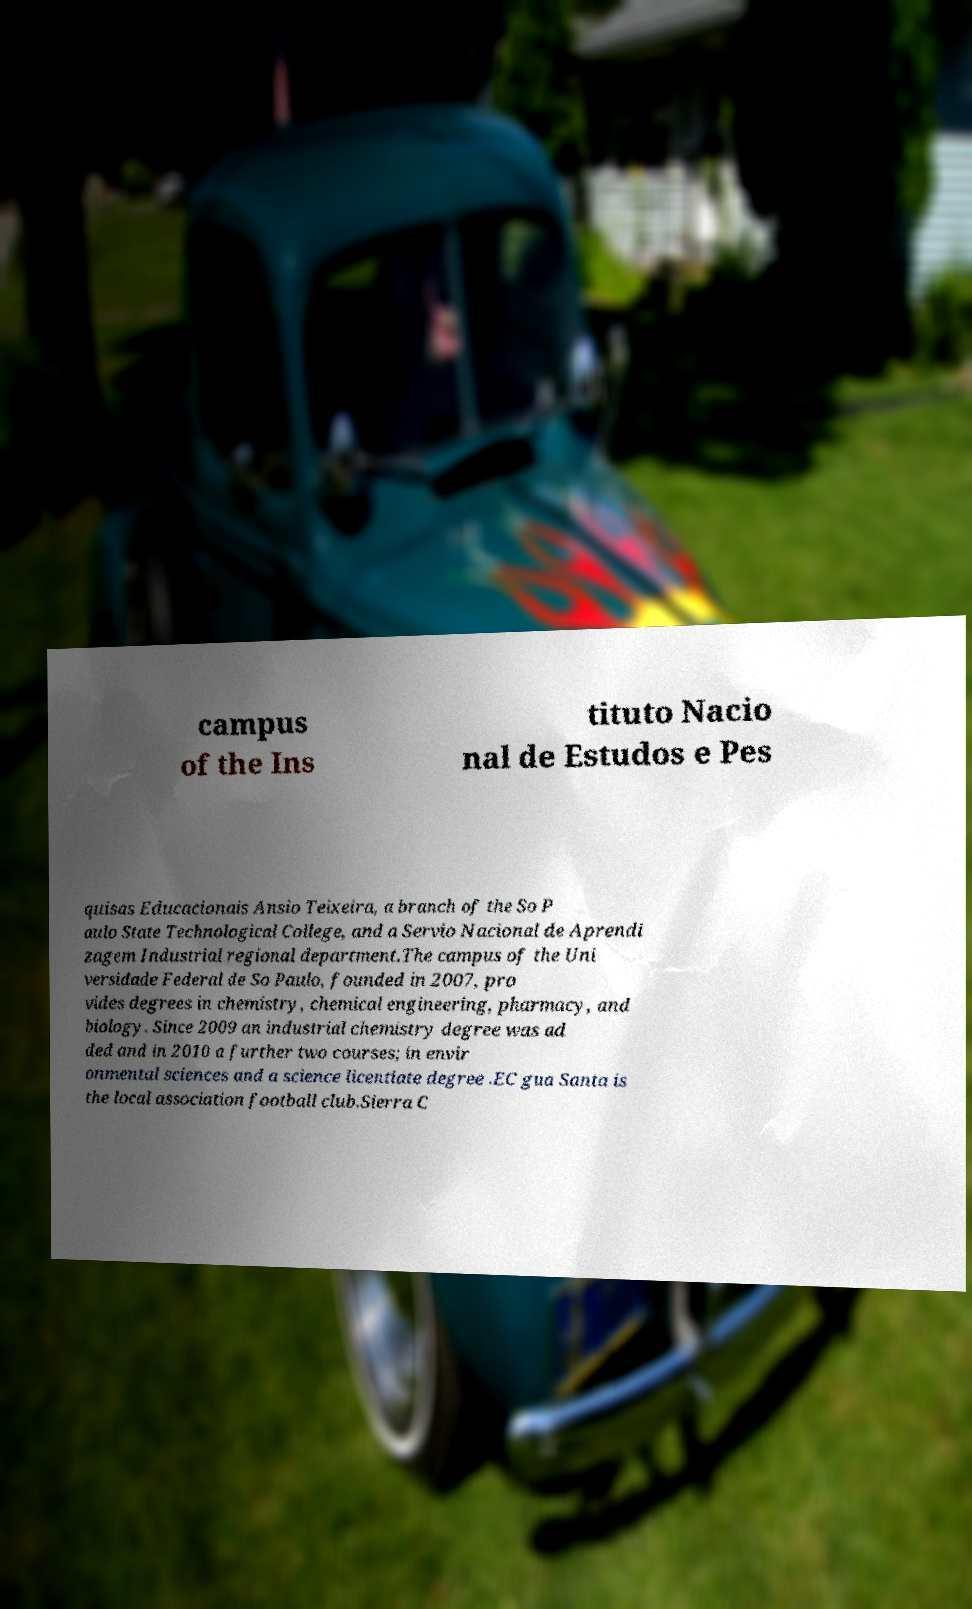Please read and relay the text visible in this image. What does it say? campus of the Ins tituto Nacio nal de Estudos e Pes quisas Educacionais Ansio Teixeira, a branch of the So P aulo State Technological College, and a Servio Nacional de Aprendi zagem Industrial regional department.The campus of the Uni versidade Federal de So Paulo, founded in 2007, pro vides degrees in chemistry, chemical engineering, pharmacy, and biology. Since 2009 an industrial chemistry degree was ad ded and in 2010 a further two courses; in envir onmental sciences and a science licentiate degree .EC gua Santa is the local association football club.Sierra C 